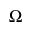Convert formula to latex. <formula><loc_0><loc_0><loc_500><loc_500>\Omega</formula> 